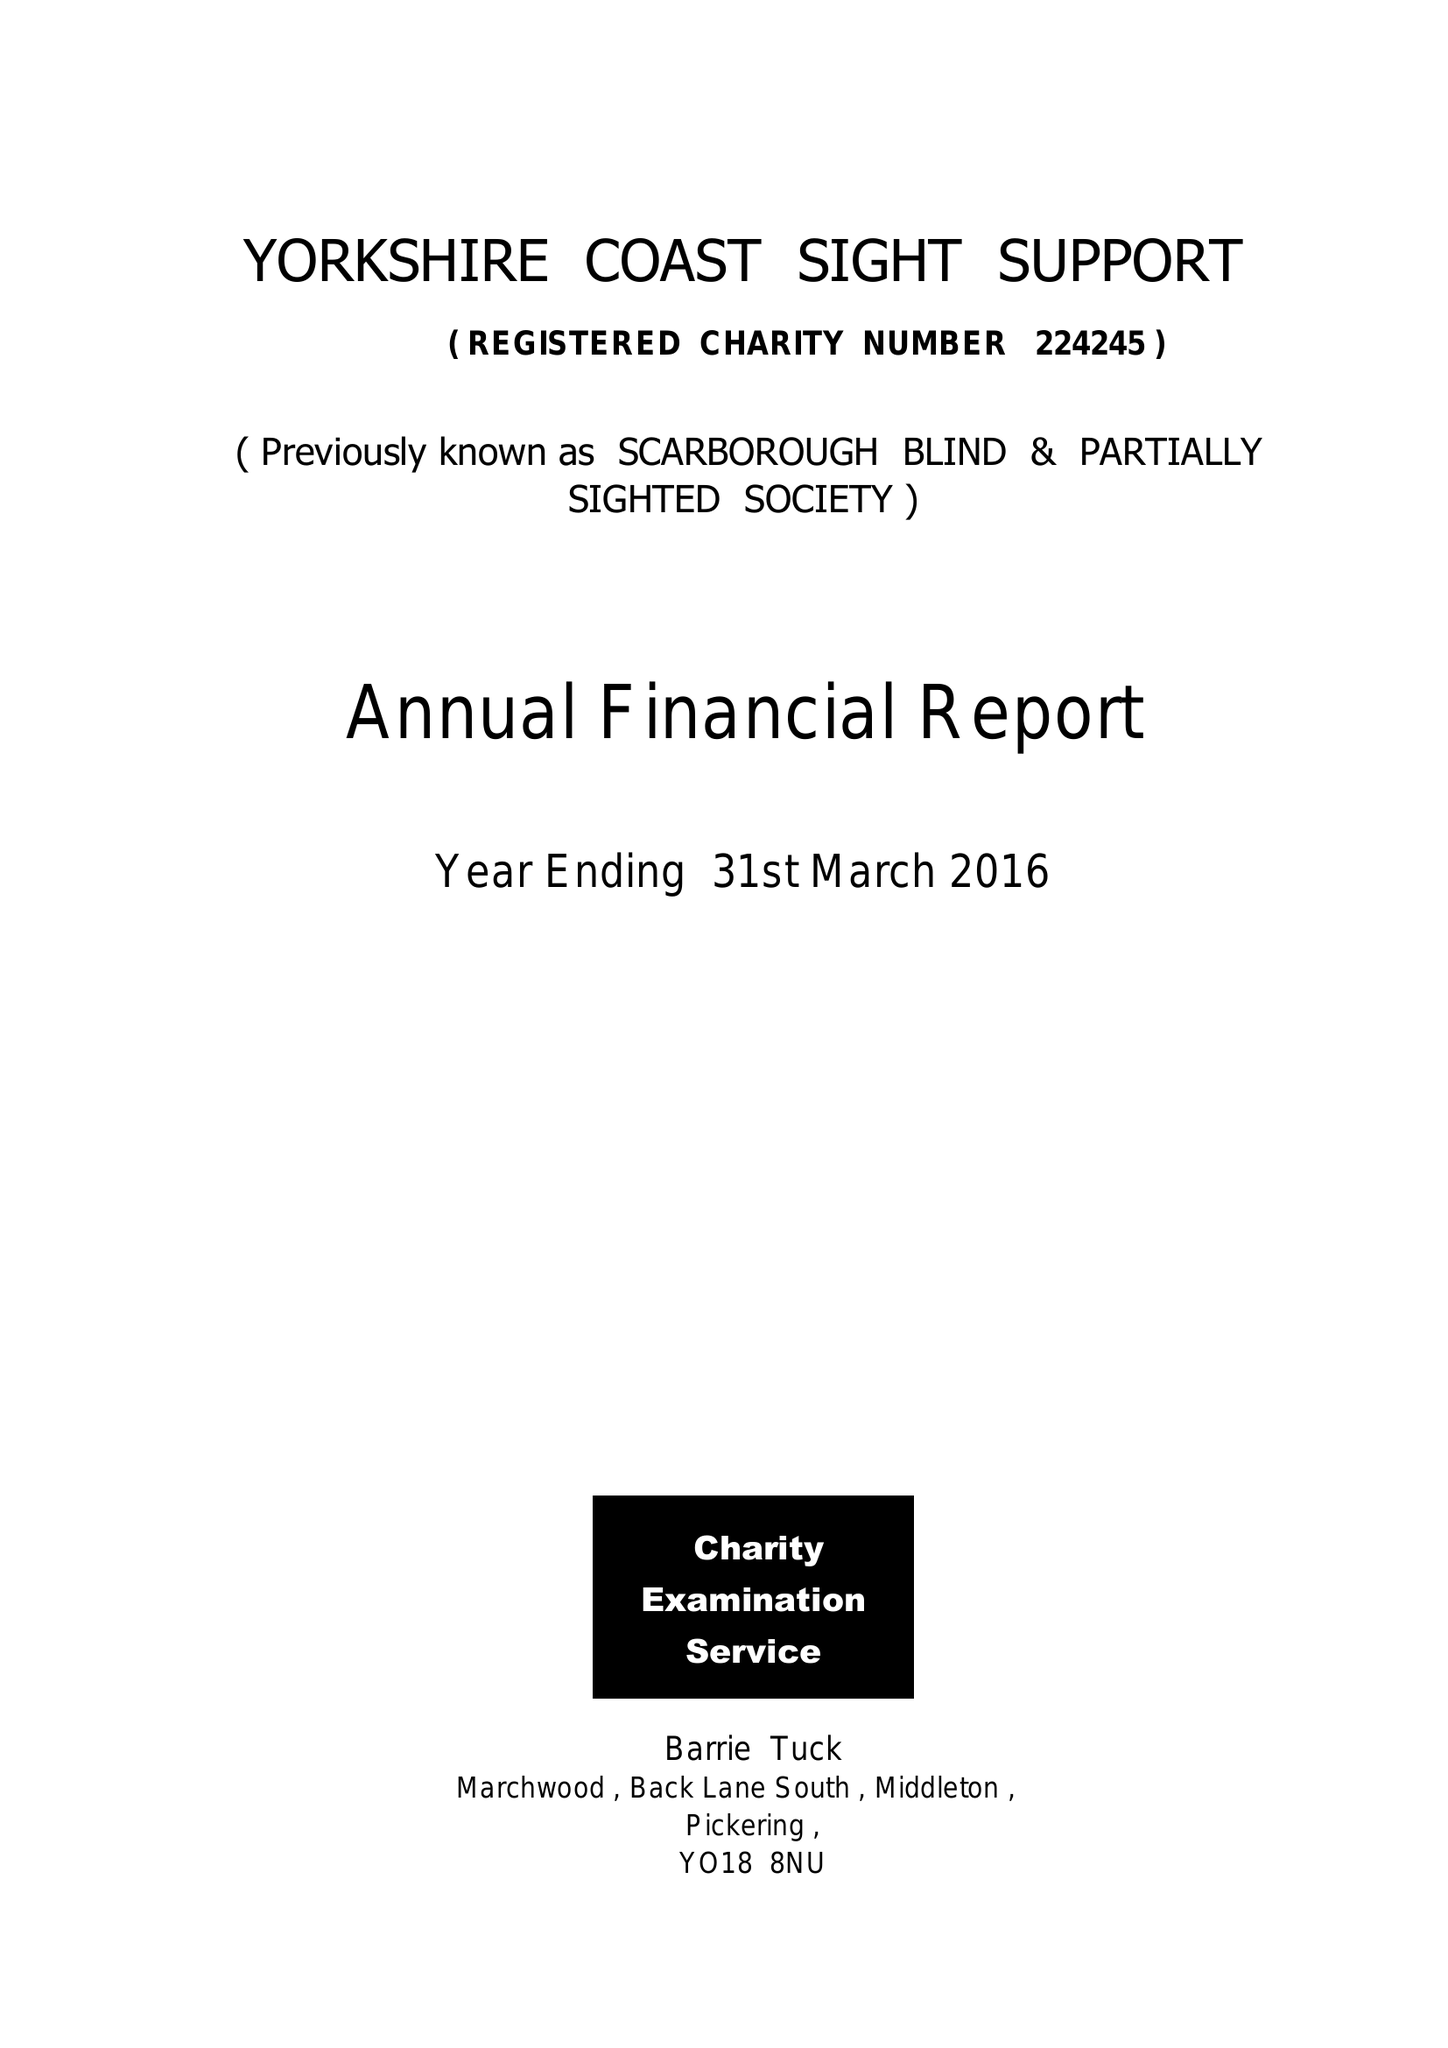What is the value for the spending_annually_in_british_pounds?
Answer the question using a single word or phrase. 69682.00 